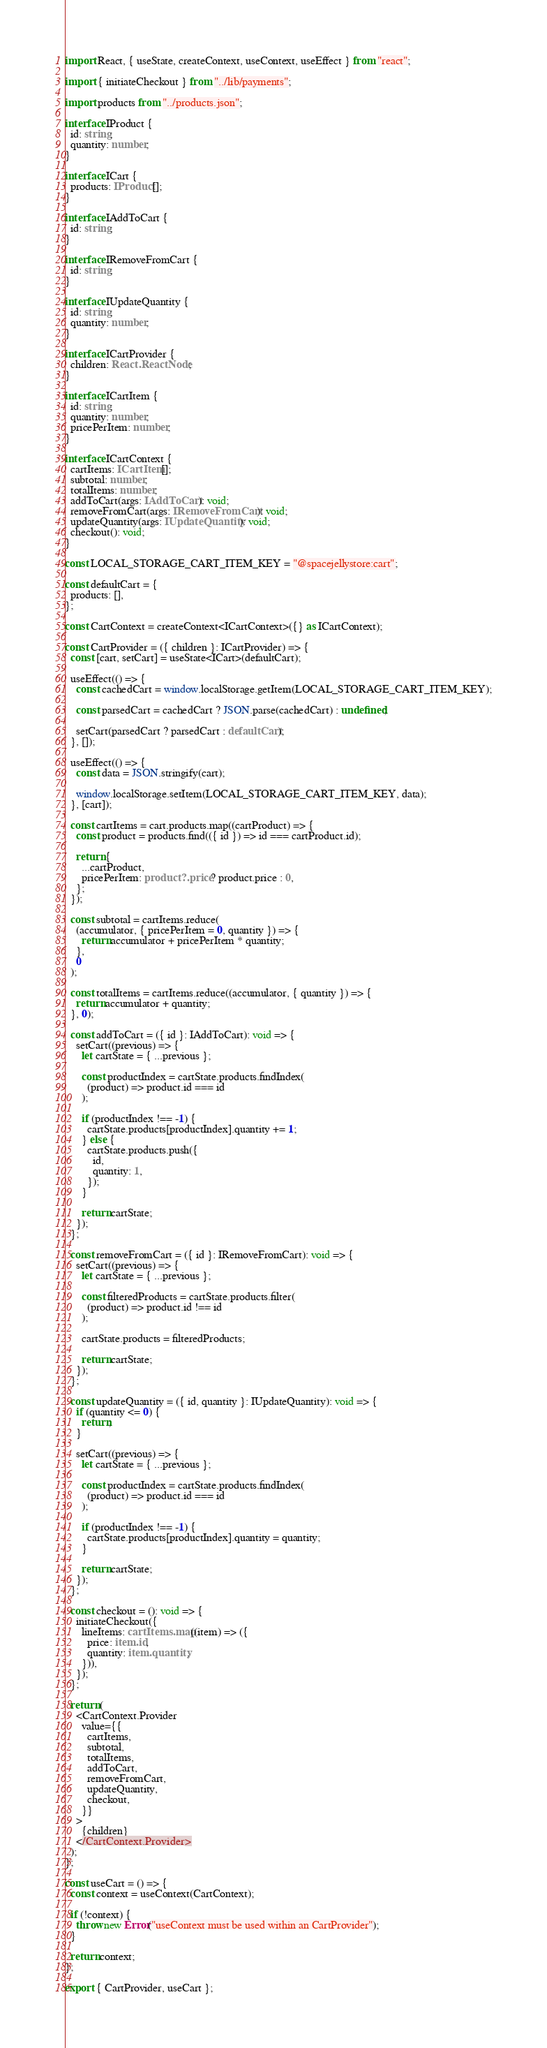Convert code to text. <code><loc_0><loc_0><loc_500><loc_500><_TypeScript_>import React, { useState, createContext, useContext, useEffect } from "react";

import { initiateCheckout } from "../lib/payments";

import products from "../products.json";

interface IProduct {
  id: string;
  quantity: number;
}

interface ICart {
  products: IProduct[];
}

interface IAddToCart {
  id: string;
}

interface IRemoveFromCart {
  id: string;
}

interface IUpdateQuantity {
  id: string;
  quantity: number;
}

interface ICartProvider {
  children: React.ReactNode;
}

interface ICartItem {
  id: string;
  quantity: number;
  pricePerItem: number;
}

interface ICartContext {
  cartItems: ICartItem[];
  subtotal: number;
  totalItems: number;
  addToCart(args: IAddToCart): void;
  removeFromCart(args: IRemoveFromCart): void;
  updateQuantity(args: IUpdateQuantity): void;
  checkout(): void;
}

const LOCAL_STORAGE_CART_ITEM_KEY = "@spacejellystore:cart";

const defaultCart = {
  products: [],
};

const CartContext = createContext<ICartContext>({} as ICartContext);

const CartProvider = ({ children }: ICartProvider) => {
  const [cart, setCart] = useState<ICart>(defaultCart);

  useEffect(() => {
    const cachedCart = window.localStorage.getItem(LOCAL_STORAGE_CART_ITEM_KEY);

    const parsedCart = cachedCart ? JSON.parse(cachedCart) : undefined;

    setCart(parsedCart ? parsedCart : defaultCart);
  }, []);

  useEffect(() => {
    const data = JSON.stringify(cart);

    window.localStorage.setItem(LOCAL_STORAGE_CART_ITEM_KEY, data);
  }, [cart]);

  const cartItems = cart.products.map((cartProduct) => {
    const product = products.find(({ id }) => id === cartProduct.id);

    return {
      ...cartProduct,
      pricePerItem: product?.price ? product.price : 0,
    };
  });

  const subtotal = cartItems.reduce(
    (accumulator, { pricePerItem = 0, quantity }) => {
      return accumulator + pricePerItem * quantity;
    },
    0
  );

  const totalItems = cartItems.reduce((accumulator, { quantity }) => {
    return accumulator + quantity;
  }, 0);

  const addToCart = ({ id }: IAddToCart): void => {
    setCart((previous) => {
      let cartState = { ...previous };

      const productIndex = cartState.products.findIndex(
        (product) => product.id === id
      );

      if (productIndex !== -1) {
        cartState.products[productIndex].quantity += 1;
      } else {
        cartState.products.push({
          id,
          quantity: 1,
        });
      }

      return cartState;
    });
  };

  const removeFromCart = ({ id }: IRemoveFromCart): void => {
    setCart((previous) => {
      let cartState = { ...previous };

      const filteredProducts = cartState.products.filter(
        (product) => product.id !== id
      );

      cartState.products = filteredProducts;

      return cartState;
    });
  };

  const updateQuantity = ({ id, quantity }: IUpdateQuantity): void => {
    if (quantity <= 0) {
      return;
    }

    setCart((previous) => {
      let cartState = { ...previous };

      const productIndex = cartState.products.findIndex(
        (product) => product.id === id
      );

      if (productIndex !== -1) {
        cartState.products[productIndex].quantity = quantity;
      }

      return cartState;
    });
  };

  const checkout = (): void => {
    initiateCheckout({
      lineItems: cartItems.map((item) => ({
        price: item.id,
        quantity: item.quantity,
      })),
    });
  };

  return (
    <CartContext.Provider
      value={{
        cartItems,
        subtotal,
        totalItems,
        addToCart,
        removeFromCart,
        updateQuantity,
        checkout,
      }}
    >
      {children}
    </CartContext.Provider>
  );
};

const useCart = () => {
  const context = useContext(CartContext);

  if (!context) {
    throw new Error("useContext must be used within an CartProvider");
  }

  return context;
};

export { CartProvider, useCart };
</code> 